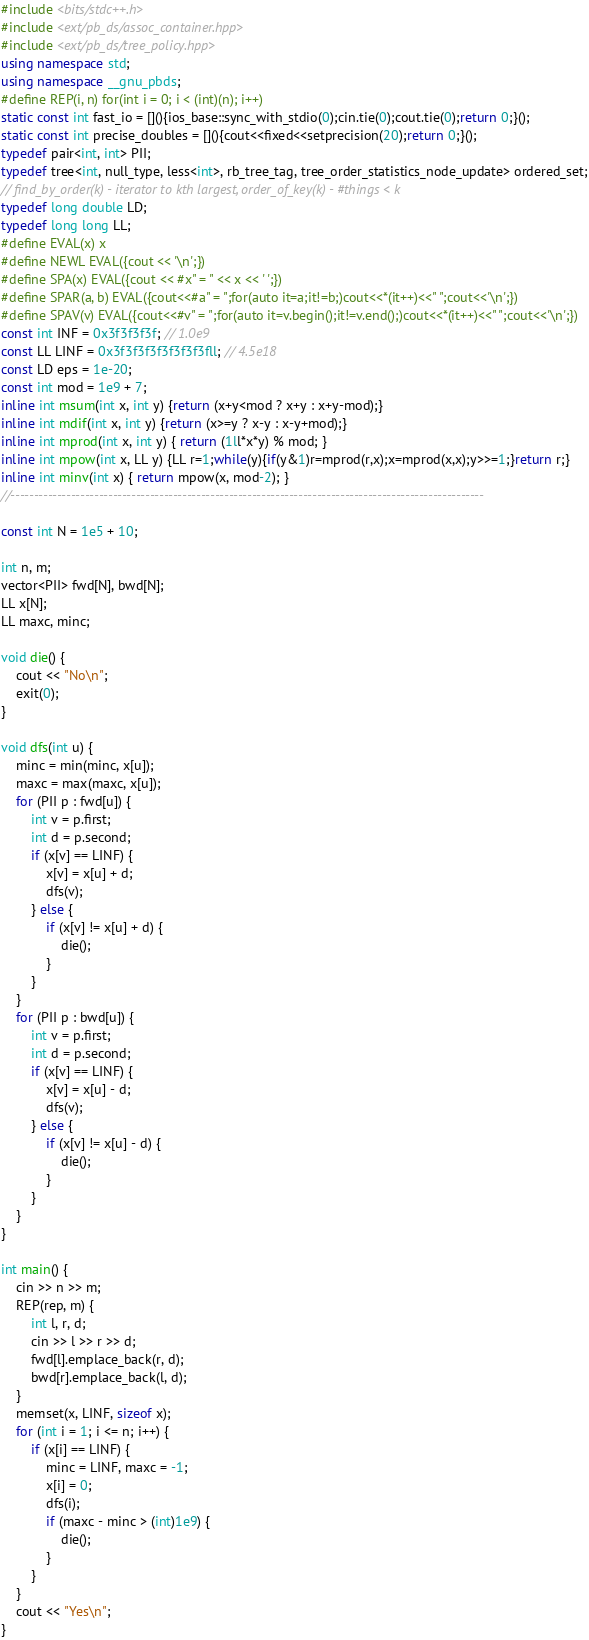Convert code to text. <code><loc_0><loc_0><loc_500><loc_500><_C++_>#include <bits/stdc++.h>
#include <ext/pb_ds/assoc_container.hpp>
#include <ext/pb_ds/tree_policy.hpp>
using namespace std;
using namespace __gnu_pbds;
#define REP(i, n) for(int i = 0; i < (int)(n); i++)
static const int fast_io = [](){ios_base::sync_with_stdio(0);cin.tie(0);cout.tie(0);return 0;}();
static const int precise_doubles = [](){cout<<fixed<<setprecision(20);return 0;}();
typedef pair<int, int> PII;
typedef tree<int, null_type, less<int>, rb_tree_tag, tree_order_statistics_node_update> ordered_set;
// find_by_order(k) - iterator to kth largest, order_of_key(k) - #things < k
typedef long double LD;
typedef long long LL;
#define EVAL(x) x
#define NEWL EVAL({cout << '\n';})
#define SPA(x) EVAL({cout << #x" = " << x << ' ';})
#define SPAR(a, b) EVAL({cout<<#a" = ";for(auto it=a;it!=b;)cout<<*(it++)<<" ";cout<<'\n';})
#define SPAV(v) EVAL({cout<<#v" = ";for(auto it=v.begin();it!=v.end();)cout<<*(it++)<<" ";cout<<'\n';})
const int INF = 0x3f3f3f3f; // 1.0e9
const LL LINF = 0x3f3f3f3f3f3f3f3fll; // 4.5e18
const LD eps = 1e-20;
const int mod = 1e9 + 7;
inline int msum(int x, int y) {return (x+y<mod ? x+y : x+y-mod);}
inline int mdif(int x, int y) {return (x>=y ? x-y : x-y+mod);}
inline int mprod(int x, int y) { return (1ll*x*y) % mod; }
inline int mpow(int x, LL y) {LL r=1;while(y){if(y&1)r=mprod(r,x);x=mprod(x,x);y>>=1;}return r;}
inline int minv(int x) { return mpow(x, mod-2); }
//------------------------------------------------------------------------------------------------------

const int N = 1e5 + 10;

int n, m;
vector<PII> fwd[N], bwd[N];
LL x[N];
LL maxc, minc;

void die() {
    cout << "No\n";
    exit(0);
}

void dfs(int u) {
    minc = min(minc, x[u]);
    maxc = max(maxc, x[u]);
    for (PII p : fwd[u]) {
        int v = p.first;
        int d = p.second;
        if (x[v] == LINF) {
            x[v] = x[u] + d;
            dfs(v);
        } else {
            if (x[v] != x[u] + d) {
                die();
            }
        }
    }
    for (PII p : bwd[u]) {
        int v = p.first;
        int d = p.second;
        if (x[v] == LINF) {
            x[v] = x[u] - d;
            dfs(v);
        } else {
            if (x[v] != x[u] - d) {
                die();
            }
        }
    }
}

int main() {
    cin >> n >> m;
    REP(rep, m) {
        int l, r, d;
        cin >> l >> r >> d;
        fwd[l].emplace_back(r, d);
        bwd[r].emplace_back(l, d);
    }
    memset(x, LINF, sizeof x);
    for (int i = 1; i <= n; i++) {
        if (x[i] == LINF) {
            minc = LINF, maxc = -1;
            x[i] = 0;
            dfs(i);
            if (maxc - minc > (int)1e9) {
                die();
            }
        }
    }
    cout << "Yes\n";
}




























</code> 